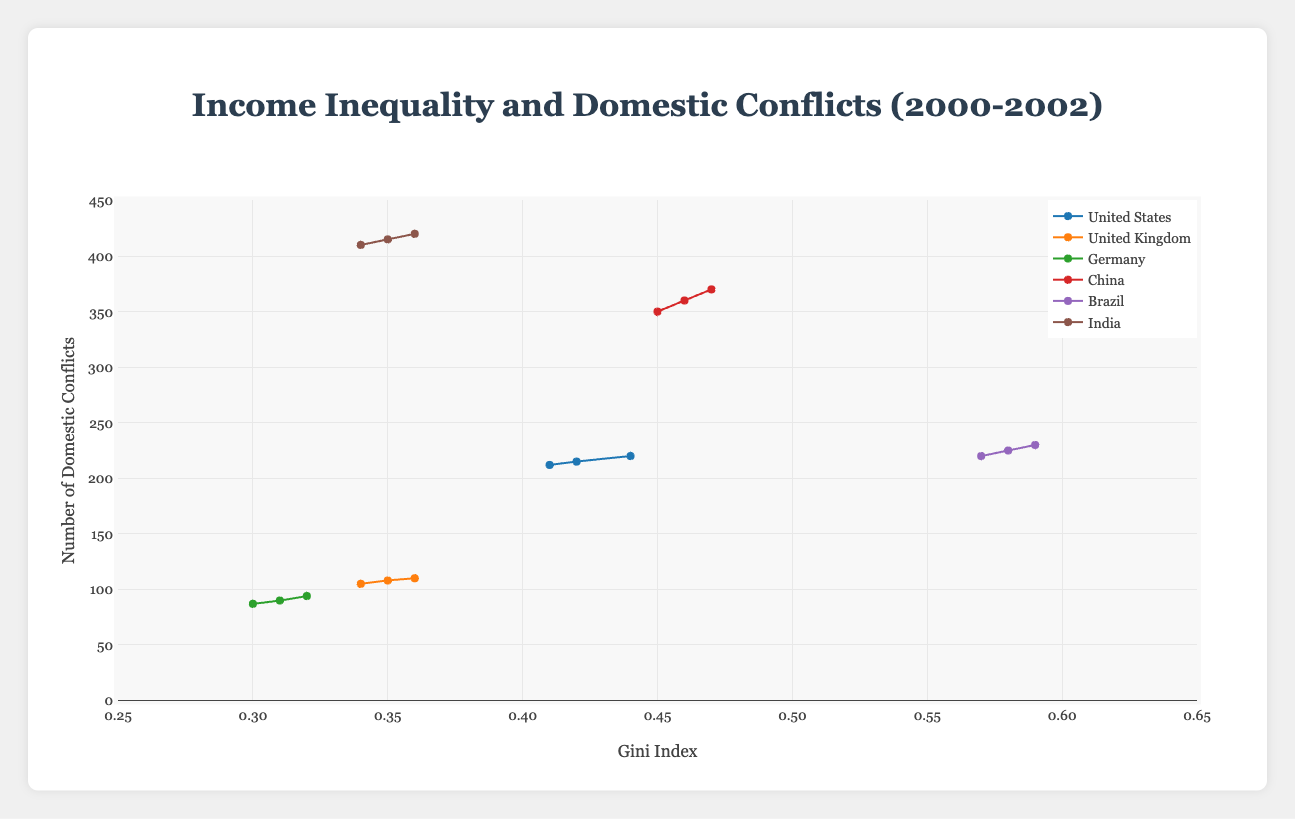What is the country with the highest Gini index in 2002? The figure shows Gini index values for each country over the years. By observing the paths of the countries for the year 2002, Brazil has the highest Gini index at 0.59.
Answer: Brazil Which country had the lowest number of domestic conflicts in 2000? In the visual representation, we can see the domestic conflicts associated with each country. For the year 2000, Germany had the lowest number of domestic conflicts at 87.
Answer: Germany How did the number of domestic conflicts in India change from 2000 to 2002? Tracing the path for India between these two years in the figure shows an increase from 410 in 2000 to 420 in 2002, which is an increase of 10 conflicts.
Answer: Increased by 10 conflicts Compare the Gini index and domestic conflicts of Germany and the United Kingdom in 2002. Looking at the figure for the year 2002, Germany’s Gini index is 0.32 with 94 domestic conflicts, while the United Kingdom’s Gini index is 0.36 with 110 domestic conflicts.
Answer: Germany: 0.32 Gini; 94 conflicts; UK: 0.36 Gini; 110 conflicts What trend do you observe in the Gini index for China from 2000 to 2002? Examining the plot line for China reveals a consistent increase in the Gini index from 0.45 in 2000 to 0.47 in 2002, indicating a widening income inequality.
Answer: Increasing trend By how much did the Gini index and domestic conflicts increase in the United States between 2000 and 2002? For the USA, the Gini index increased from 0.41 to 0.44 (an increase of 0.03), and domestic conflicts rose from 212 to 220 (an increase of 8).
Answer: Gini index increased by 0.03; conflicts increased by 8 Which country had the steepest increase in domestic conflicts between 2000 and 2002? Analyzing the slopes of the lines for each country between 2000 and 2002, India had the highest increase in domestic conflicts, growing from 410 to 420, which is an increase of 10 conflicts.
Answer: India If you average the domestic conflicts of the United Kingdom across the years shown, what is the result? Summing domestic conflicts for the United Kingdom (105 in 2000, 108 in 2001, 110 in 2002) yields 323. Dividing by 3 for the average, we get 107.67 (rounded to two decimal places).
Answer: 107.67 How do the domestic conflicts in Brazil compare to those in India during 2001? In 2001, Brazil had 225 conflicts while India had 415 conflicts, so comparing shows that India had significantly more domestic conflicts than Brazil in that year.
Answer: India had more conflicts Does a higher Gini index correlate with more domestic conflicts across these countries? Observing the overall trend, countries with higher Gini indices, such as Brazil, China, and India, tend to have higher domestic conflicts compared to countries with lower Gini indices like Germany and the United Kingdom.
Answer: Generally yes 